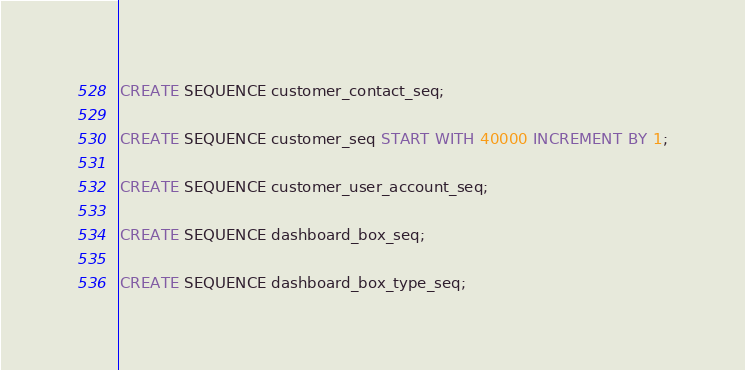<code> <loc_0><loc_0><loc_500><loc_500><_SQL_>CREATE SEQUENCE customer_contact_seq;

CREATE SEQUENCE customer_seq START WITH 40000 INCREMENT BY 1;

CREATE SEQUENCE customer_user_account_seq;

CREATE SEQUENCE dashboard_box_seq;

CREATE SEQUENCE dashboard_box_type_seq;
</code> 